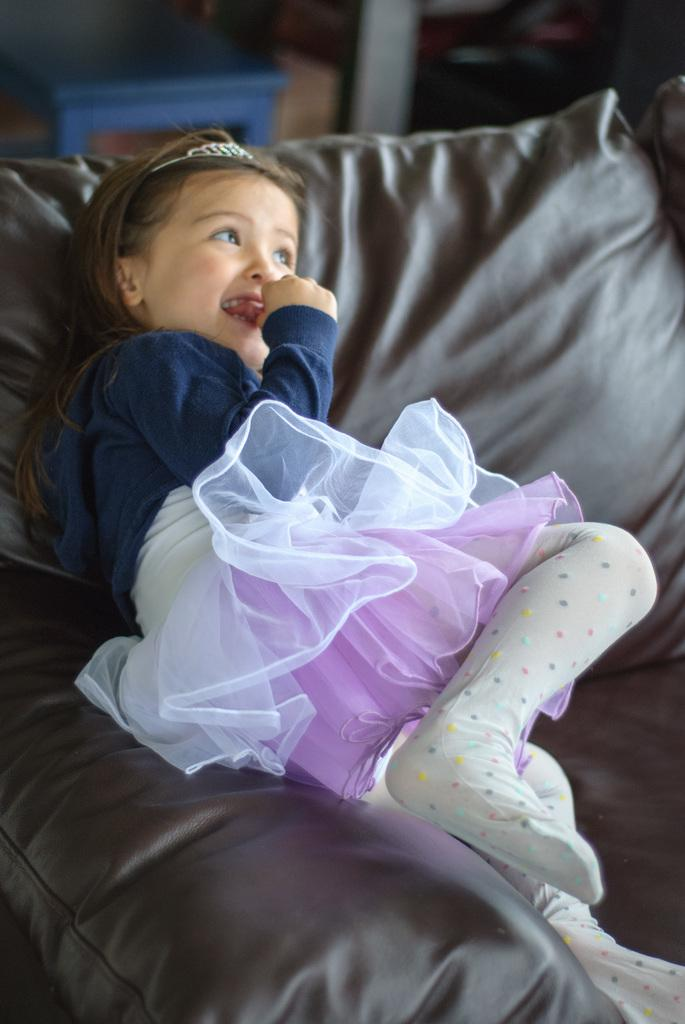Who is the main subject in the image? There is a girl in the image. What is the girl wearing? The girl is wearing a blue, white, and pink dress. Where is the girl located in the image? The girl is laying on a brown couch. What else can be seen in the image besides the girl? There are other objects visible objects in the background of the image. What type of paper is the girl holding in the image? There is no paper visible in the image; the girl is laying on a brown couch and wearing a blue, white, and pink dress. 